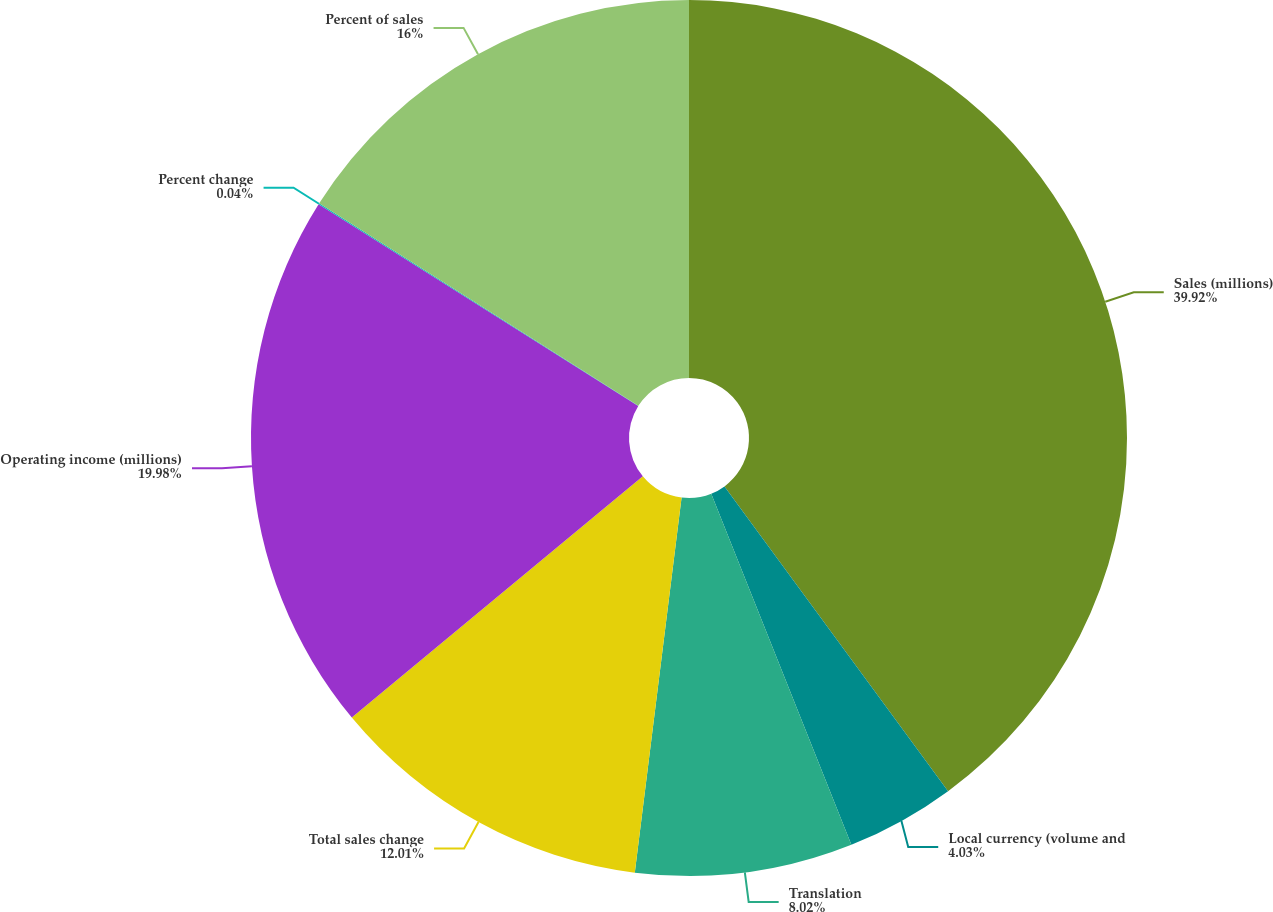Convert chart. <chart><loc_0><loc_0><loc_500><loc_500><pie_chart><fcel>Sales (millions)<fcel>Local currency (volume and<fcel>Translation<fcel>Total sales change<fcel>Operating income (millions)<fcel>Percent change<fcel>Percent of sales<nl><fcel>39.93%<fcel>4.03%<fcel>8.02%<fcel>12.01%<fcel>19.98%<fcel>0.04%<fcel>16.0%<nl></chart> 